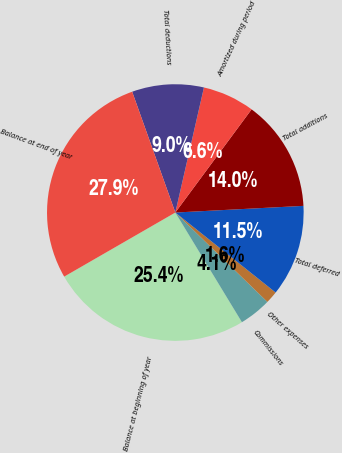Convert chart to OTSL. <chart><loc_0><loc_0><loc_500><loc_500><pie_chart><fcel>Balance at beginning of year<fcel>Commissions<fcel>Other expenses<fcel>Total deferred<fcel>Total additions<fcel>Amortized during period<fcel>Total deductions<fcel>Balance at end of year<nl><fcel>25.36%<fcel>4.05%<fcel>1.55%<fcel>11.54%<fcel>14.04%<fcel>6.55%<fcel>9.04%<fcel>27.86%<nl></chart> 